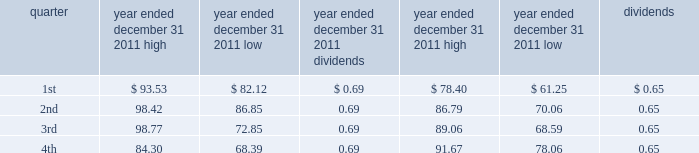Part ii item 5 .
Market for registrant 2019s common equity , related stockholder matters and issuer purchases of equity securities vornado 2019s common shares are traded on the new york stock exchange under the symbol 201cvno . 201d quarterly high and low sales prices of the common shares and dividends paid per share for the years ended december 31 , 2011 and 2010 were as follows : year ended year ended december 31 , 2011 december 31 , 2010 .
As of february 1 , 2012 , there were 1230 holders of record of our common shares .
Recent sales of unregistered securities during the fourth quarter of 2011 , we issued 20891 common shares upon the redemption of class a units of the operating partnership held by persons who received units , in private placements in earlier periods , in exchange for their interests in limited partnerships that owned real estate .
The common shares were issued without registration under the securities act of 1933 in reliance on section 4 ( 2 ) of that act .
Information relating to compensation plans under which our equity securities are authorized for issuance is set forth under part iii , item 12 of this annual report on form 10-k and such information is incorporated by reference herein .
Recent purchases of equity securities in december 2011 , we received 410783 vornado common shares at an average price of $ 76.36 per share as payment for the exercise of certain employee options. .
In december 2011 , what was the total dollar value of the vornado common shares rceived as payment for the exercise of certain employee options? 
Computations: (76.36 * 410783)
Answer: 31367389.88. 